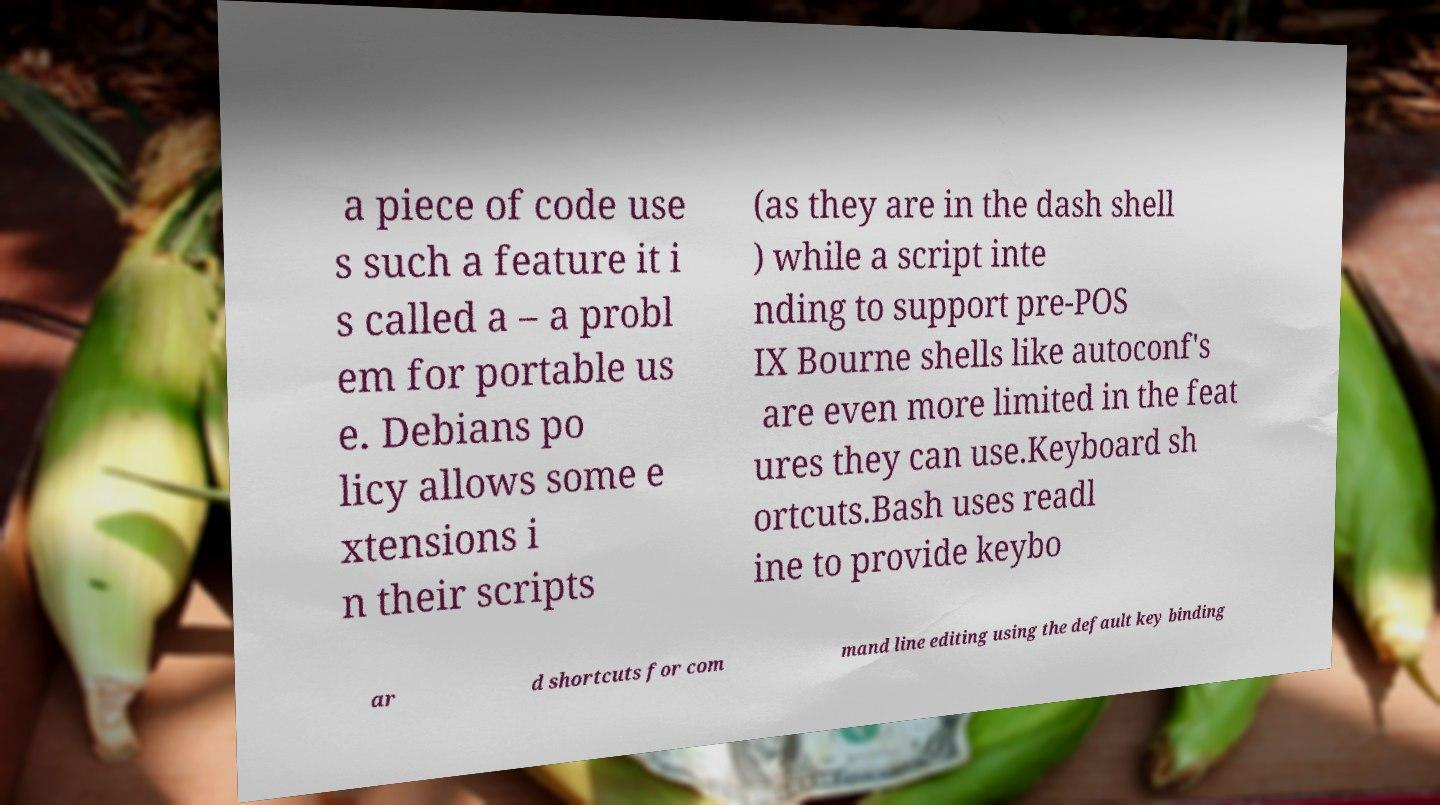Can you accurately transcribe the text from the provided image for me? a piece of code use s such a feature it i s called a – a probl em for portable us e. Debians po licy allows some e xtensions i n their scripts (as they are in the dash shell ) while a script inte nding to support pre-POS IX Bourne shells like autoconf's are even more limited in the feat ures they can use.Keyboard sh ortcuts.Bash uses readl ine to provide keybo ar d shortcuts for com mand line editing using the default key binding 